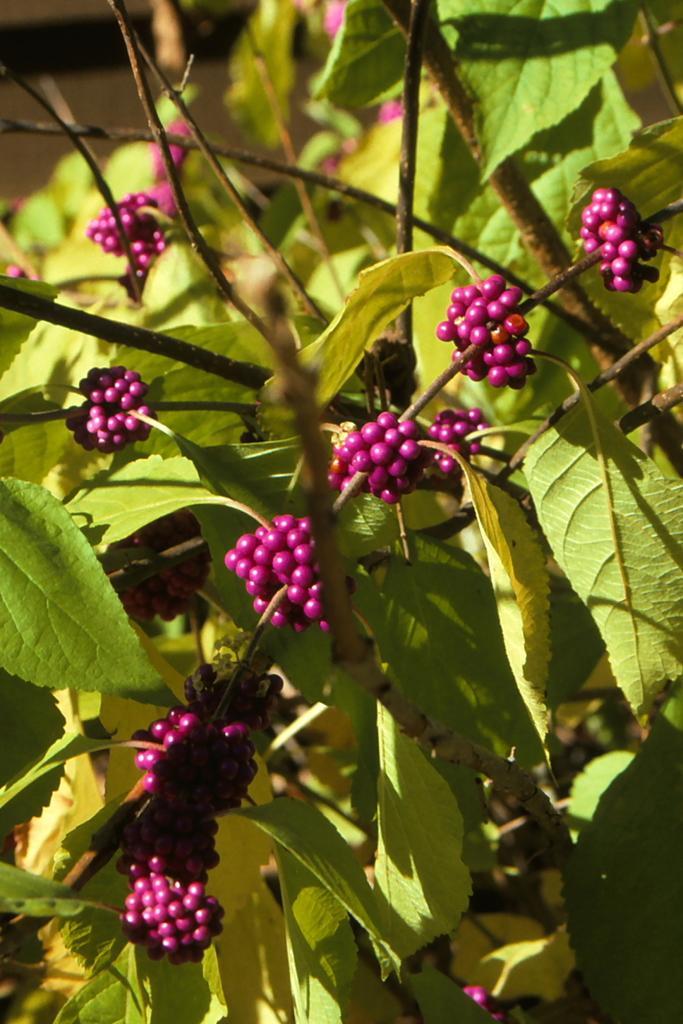Could you give a brief overview of what you see in this image? Here we can see a plant with berries and we can see green leaves. 